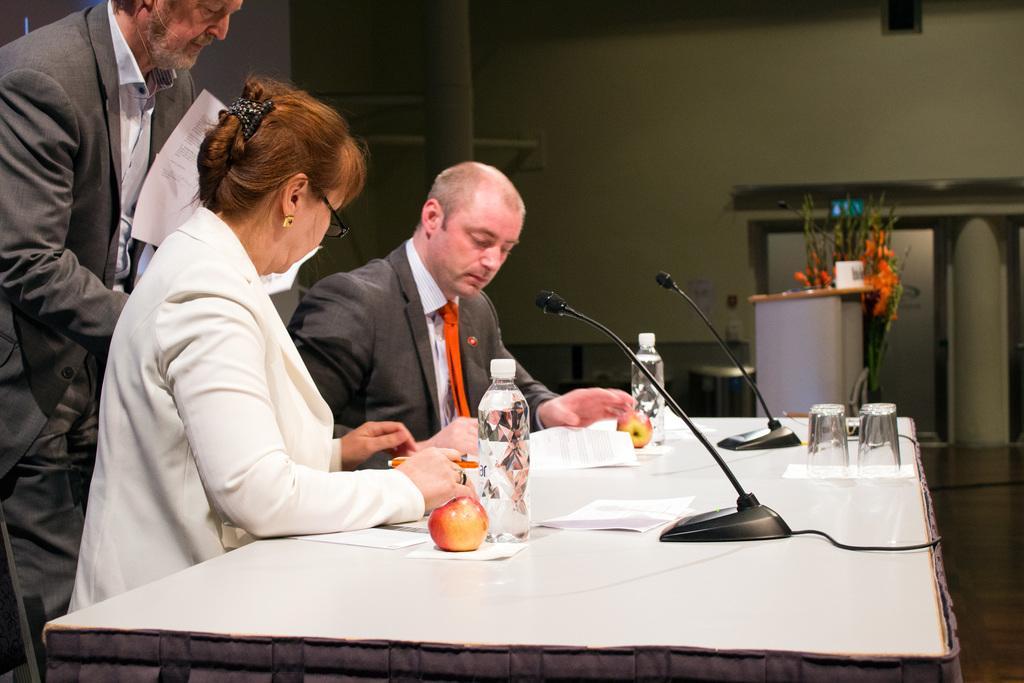Could you give a brief overview of what you see in this image? In this image there is a woman and a man sitting on the chairs at a table. They are holding pens in their hands. On the table there are microphones, glasses, bottles, papers, tissues and apples. Behind them there is another man standing. He is holding papers in his hand. Beside the table there is a podium. There are flowers and a cup on the podium. Behind it there is a cupboard to the wall. 